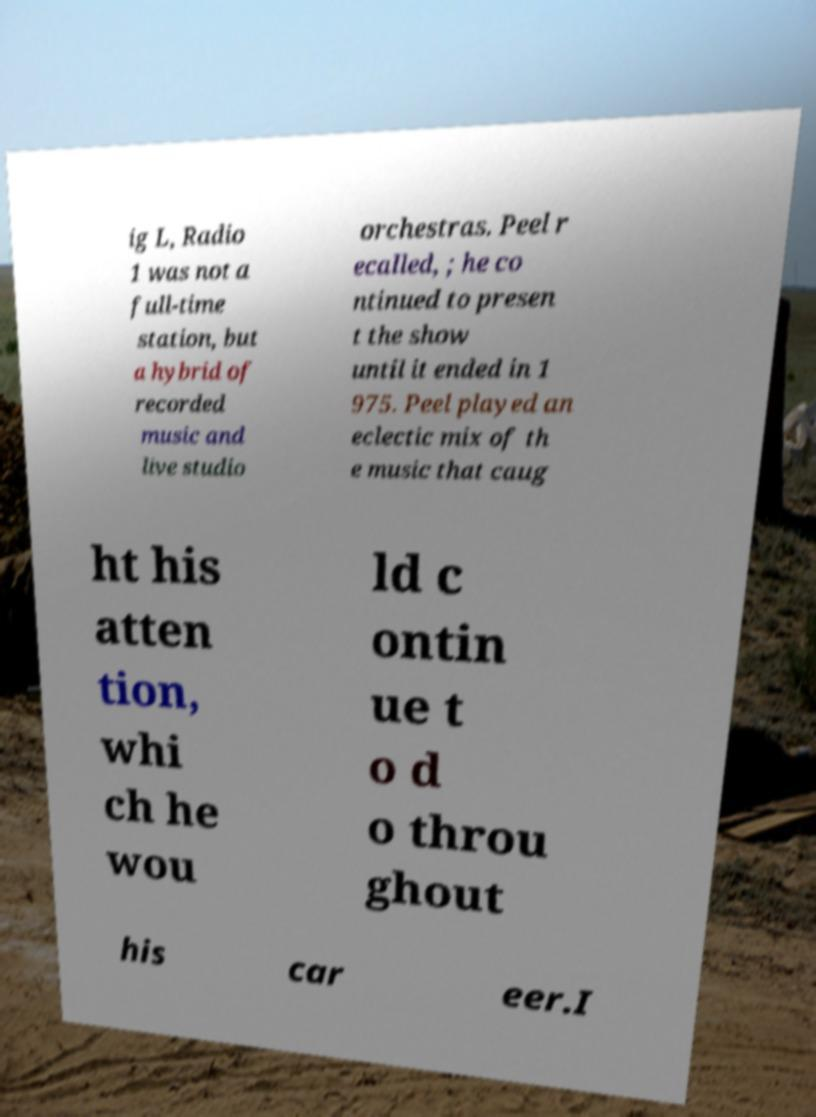Please read and relay the text visible in this image. What does it say? ig L, Radio 1 was not a full-time station, but a hybrid of recorded music and live studio orchestras. Peel r ecalled, ; he co ntinued to presen t the show until it ended in 1 975. Peel played an eclectic mix of th e music that caug ht his atten tion, whi ch he wou ld c ontin ue t o d o throu ghout his car eer.I 